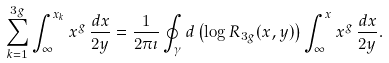<formula> <loc_0><loc_0><loc_500><loc_500>\sum _ { k = 1 } ^ { 3 g } \int _ { \infty } ^ { x _ { k } } x ^ { g } \, \frac { d x } { 2 y } = \frac { 1 } { 2 \pi \imath } \oint _ { \gamma } d \left ( \log R _ { 3 g } ( x , y ) \right ) \int _ { \infty } ^ { x } x ^ { g } \, \frac { d x } { 2 y } .</formula> 